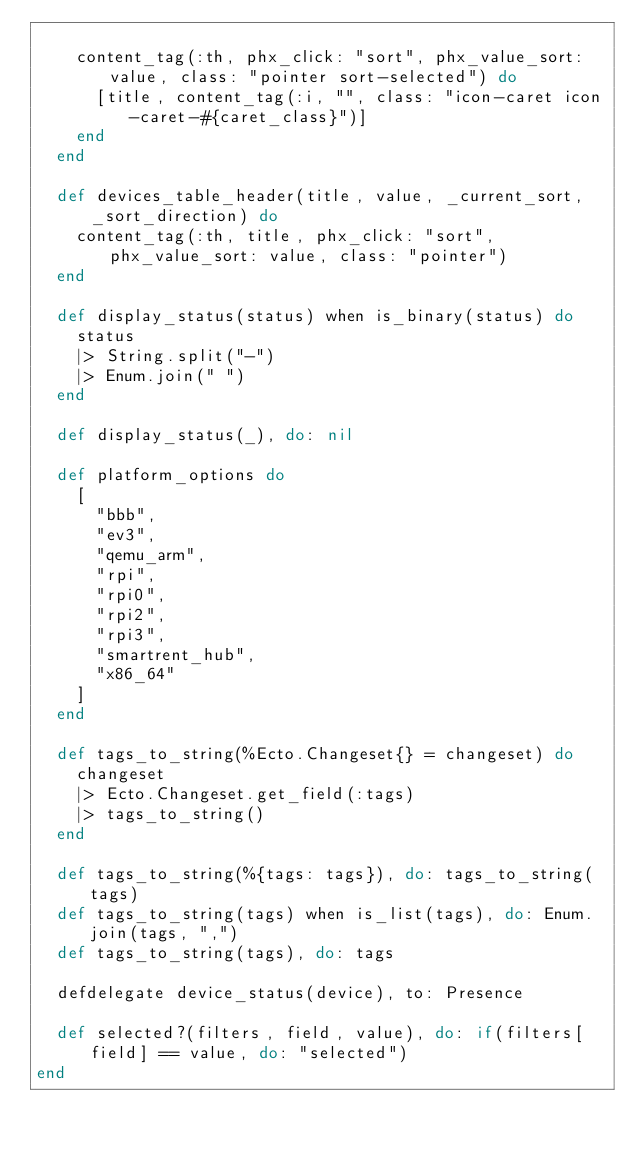<code> <loc_0><loc_0><loc_500><loc_500><_Elixir_>
    content_tag(:th, phx_click: "sort", phx_value_sort: value, class: "pointer sort-selected") do
      [title, content_tag(:i, "", class: "icon-caret icon-caret-#{caret_class}")]
    end
  end

  def devices_table_header(title, value, _current_sort, _sort_direction) do
    content_tag(:th, title, phx_click: "sort", phx_value_sort: value, class: "pointer")
  end

  def display_status(status) when is_binary(status) do
    status
    |> String.split("-")
    |> Enum.join(" ")
  end

  def display_status(_), do: nil

  def platform_options do
    [
      "bbb",
      "ev3",
      "qemu_arm",
      "rpi",
      "rpi0",
      "rpi2",
      "rpi3",
      "smartrent_hub",
      "x86_64"
    ]
  end

  def tags_to_string(%Ecto.Changeset{} = changeset) do
    changeset
    |> Ecto.Changeset.get_field(:tags)
    |> tags_to_string()
  end

  def tags_to_string(%{tags: tags}), do: tags_to_string(tags)
  def tags_to_string(tags) when is_list(tags), do: Enum.join(tags, ",")
  def tags_to_string(tags), do: tags

  defdelegate device_status(device), to: Presence

  def selected?(filters, field, value), do: if(filters[field] == value, do: "selected")
end
</code> 